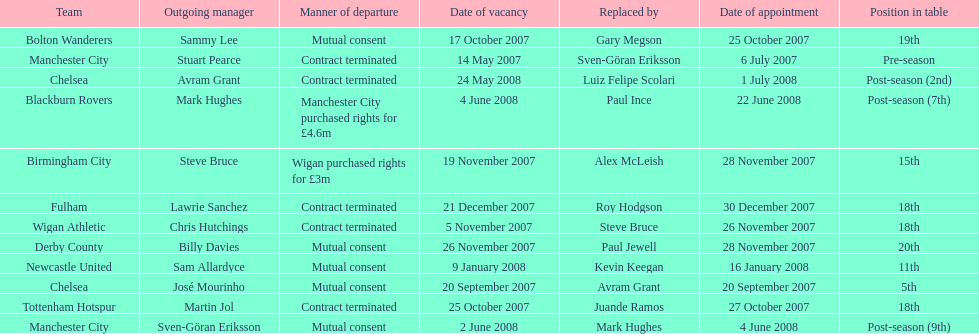For at least how many years was avram grant involved with chelsea? 1. 